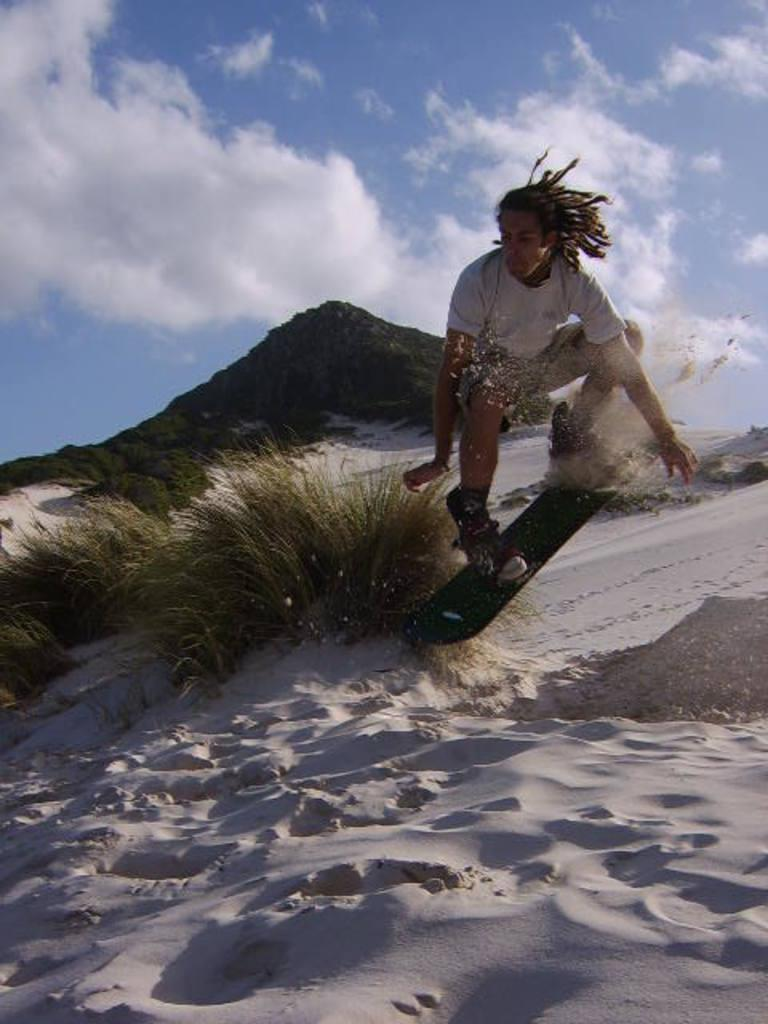What can be seen at the top of the image? The sky with clouds is visible at the top of the image. What type of vegetation is present in the image? There are bushes in the image. Who is in the image? There is a man with long hair in the image. What is the man doing in the image? The man is skating in the sand. How does the man sneeze while rollerblading in the wilderness? The image does not show the man sneezing or rollerblading, nor does it depict a wilderness setting. 